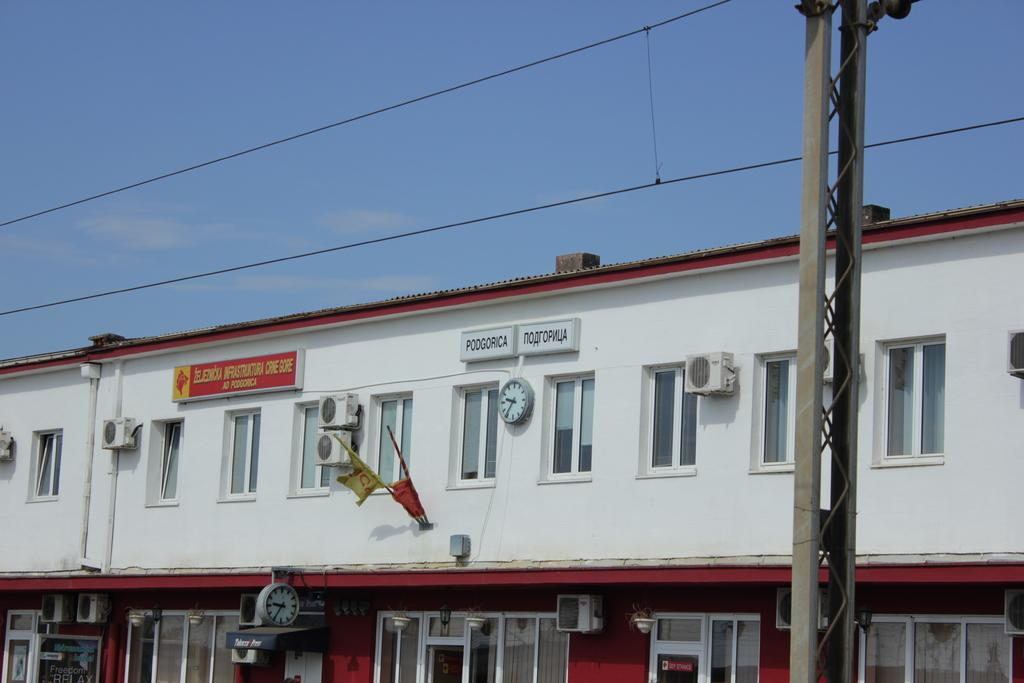What object can be seen on the wall in the image? There is a watch on the wall in the image. What type of windows does the building have? The building has glass windows. What can be seen at the top of the image? There are electric cables at the top of the image. What is visible in the background of the image? The sky is visible in the image. Can you tell me how many pets are visible in the image? There are no pets present in the image. Are there any fairies flying around the watch in the image? There are no fairies present in the image. 